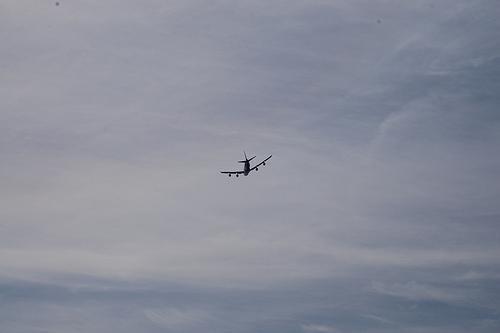How many large wings does the plane have?
Give a very brief answer. 2. 